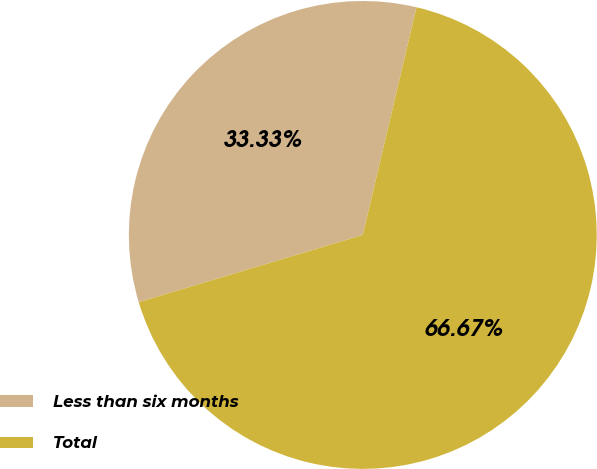Convert chart to OTSL. <chart><loc_0><loc_0><loc_500><loc_500><pie_chart><fcel>Less than six months<fcel>Total<nl><fcel>33.33%<fcel>66.67%<nl></chart> 